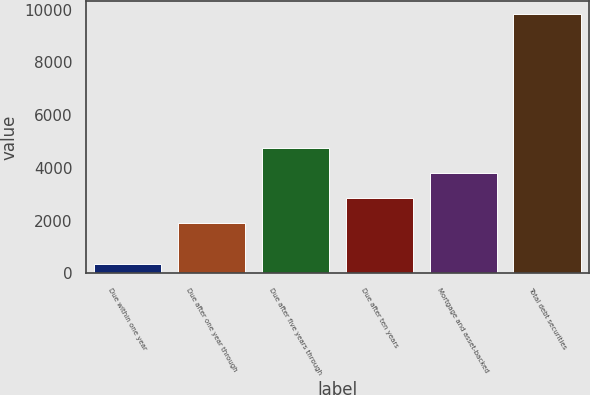<chart> <loc_0><loc_0><loc_500><loc_500><bar_chart><fcel>Due within one year<fcel>Due after one year through<fcel>Due after five years through<fcel>Due after ten years<fcel>Mortgage and asset-backed<fcel>Total debt securities<nl><fcel>362<fcel>1907<fcel>4752.5<fcel>2855.5<fcel>3804<fcel>9847<nl></chart> 